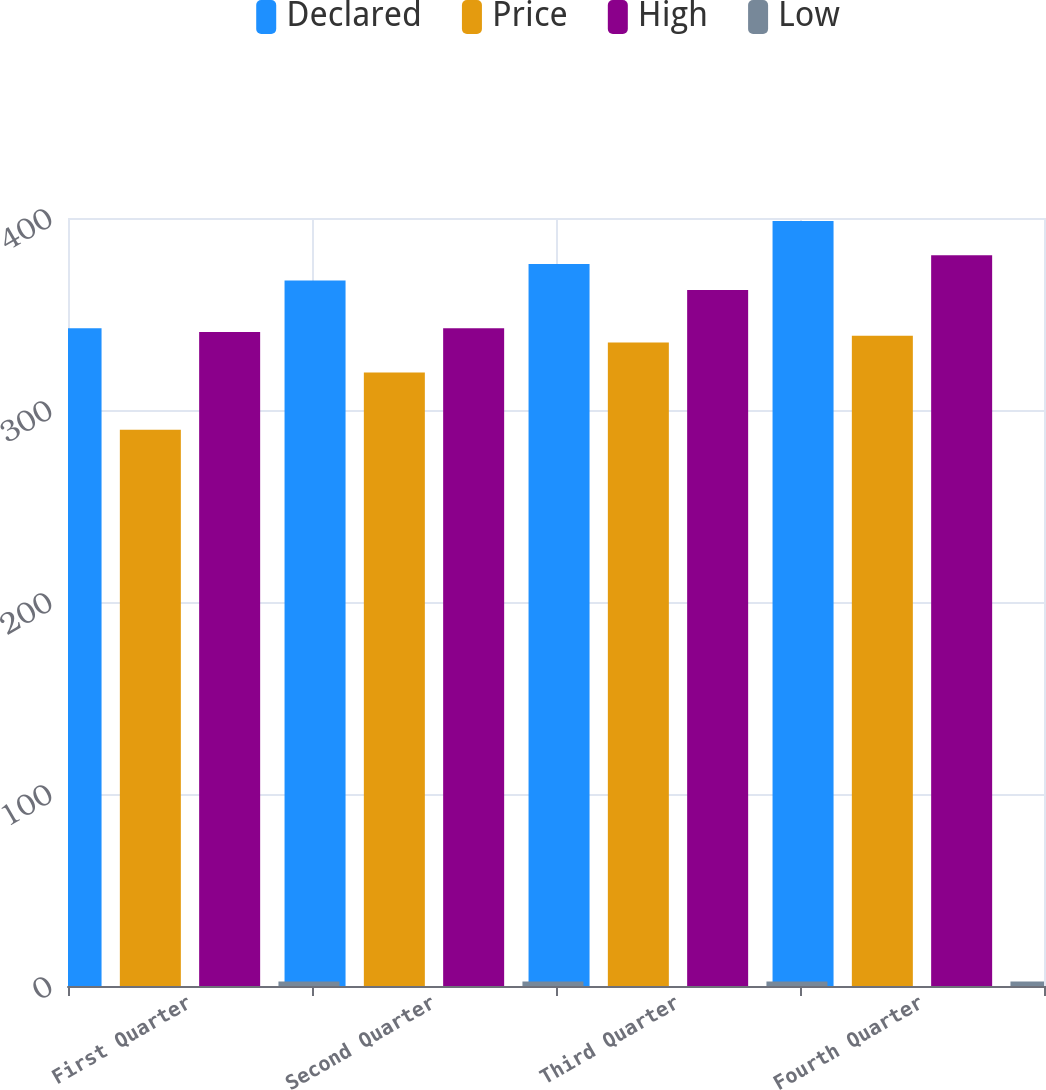<chart> <loc_0><loc_0><loc_500><loc_500><stacked_bar_chart><ecel><fcel>First Quarter<fcel>Second Quarter<fcel>Third Quarter<fcel>Fourth Quarter<nl><fcel>Declared<fcel>342.56<fcel>367.47<fcel>376<fcel>398.45<nl><fcel>Price<fcel>289.72<fcel>319.54<fcel>335.11<fcel>338.61<nl><fcel>High<fcel>340.57<fcel>342.53<fcel>362.46<fcel>380.54<nl><fcel>Low<fcel>2.29<fcel>2.29<fcel>2.29<fcel>2.29<nl></chart> 